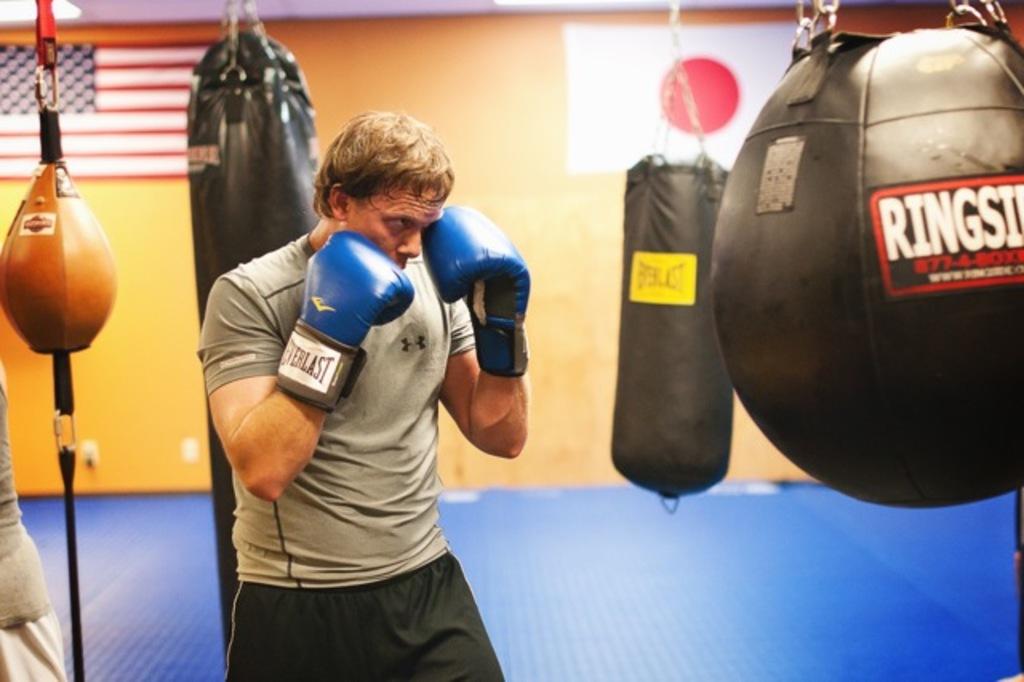Who makes the blue gloves?
Your answer should be very brief. Everlast. What kind of punching back is that?
Make the answer very short. Ringside. 